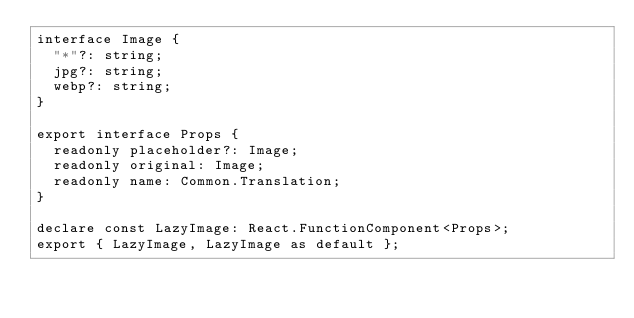Convert code to text. <code><loc_0><loc_0><loc_500><loc_500><_TypeScript_>interface Image {
  "*"?: string;
  jpg?: string;
  webp?: string;
}

export interface Props {
  readonly placeholder?: Image;
  readonly original: Image;
  readonly name: Common.Translation;
}

declare const LazyImage: React.FunctionComponent<Props>;
export { LazyImage, LazyImage as default };
</code> 